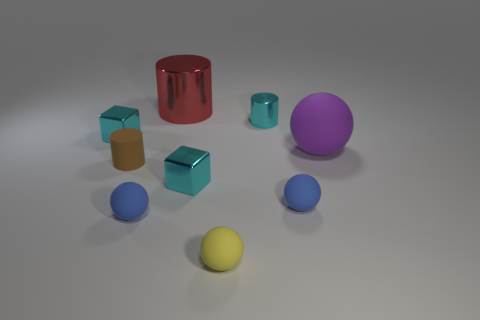There is a shiny cylinder that is the same size as the yellow thing; what color is it?
Your answer should be compact. Cyan. Are there any tiny things that have the same color as the small metallic cylinder?
Your answer should be compact. Yes. What size is the cylinder that is made of the same material as the large red thing?
Your answer should be very brief. Small. How many other objects are the same size as the red object?
Offer a very short reply. 1. There is a ball that is left of the large metallic cylinder; what is its material?
Offer a terse response. Rubber. The purple matte object that is behind the tiny cyan metal cube to the right of the small cyan metal cube left of the small brown rubber cylinder is what shape?
Your answer should be very brief. Sphere. Is the size of the cyan cylinder the same as the red thing?
Ensure brevity in your answer.  No. What number of things are rubber spheres or cyan blocks on the left side of the big red cylinder?
Offer a very short reply. 5. What number of objects are either metallic objects that are in front of the tiny shiny cylinder or objects in front of the purple matte object?
Keep it short and to the point. 6. Are there any cyan metal objects in front of the big purple thing?
Make the answer very short. Yes. 